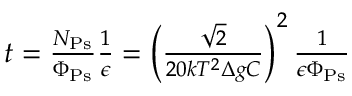Convert formula to latex. <formula><loc_0><loc_0><loc_500><loc_500>\begin{array} { r } { t = \frac { N _ { P s } } { \Phi _ { P s } } \frac { 1 } { \epsilon } = \left ( \frac { \sqrt { 2 } } { 2 0 k T ^ { 2 } \Delta g C } \right ) ^ { 2 } \frac { 1 } { \epsilon \Phi _ { P s } } } \end{array}</formula> 